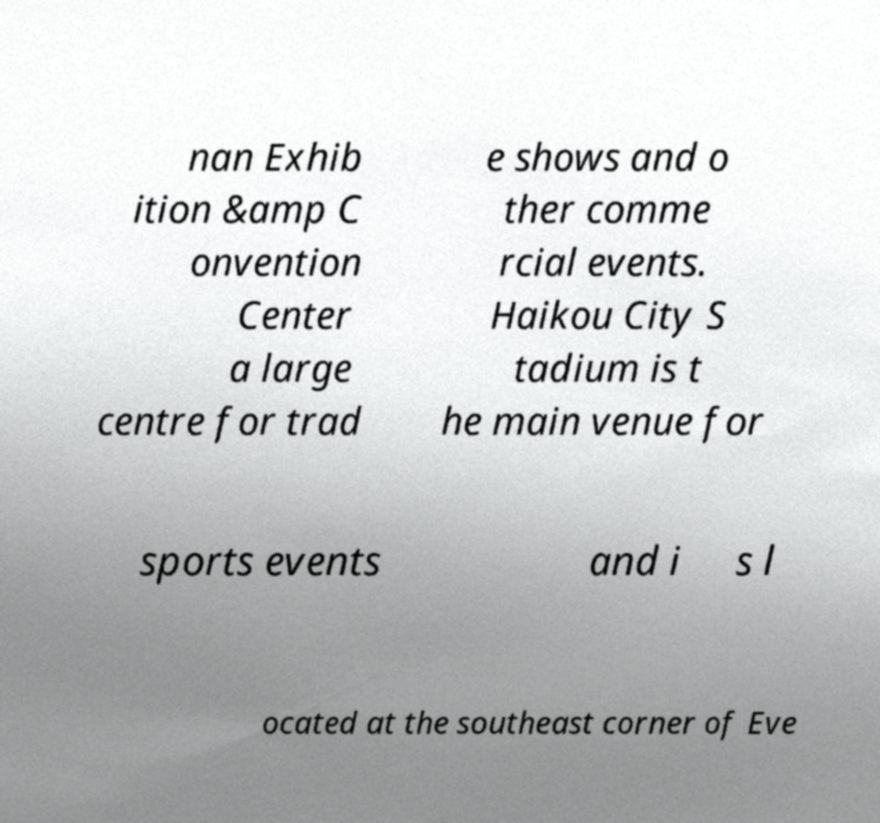Could you assist in decoding the text presented in this image and type it out clearly? nan Exhib ition &amp C onvention Center a large centre for trad e shows and o ther comme rcial events. Haikou City S tadium is t he main venue for sports events and i s l ocated at the southeast corner of Eve 